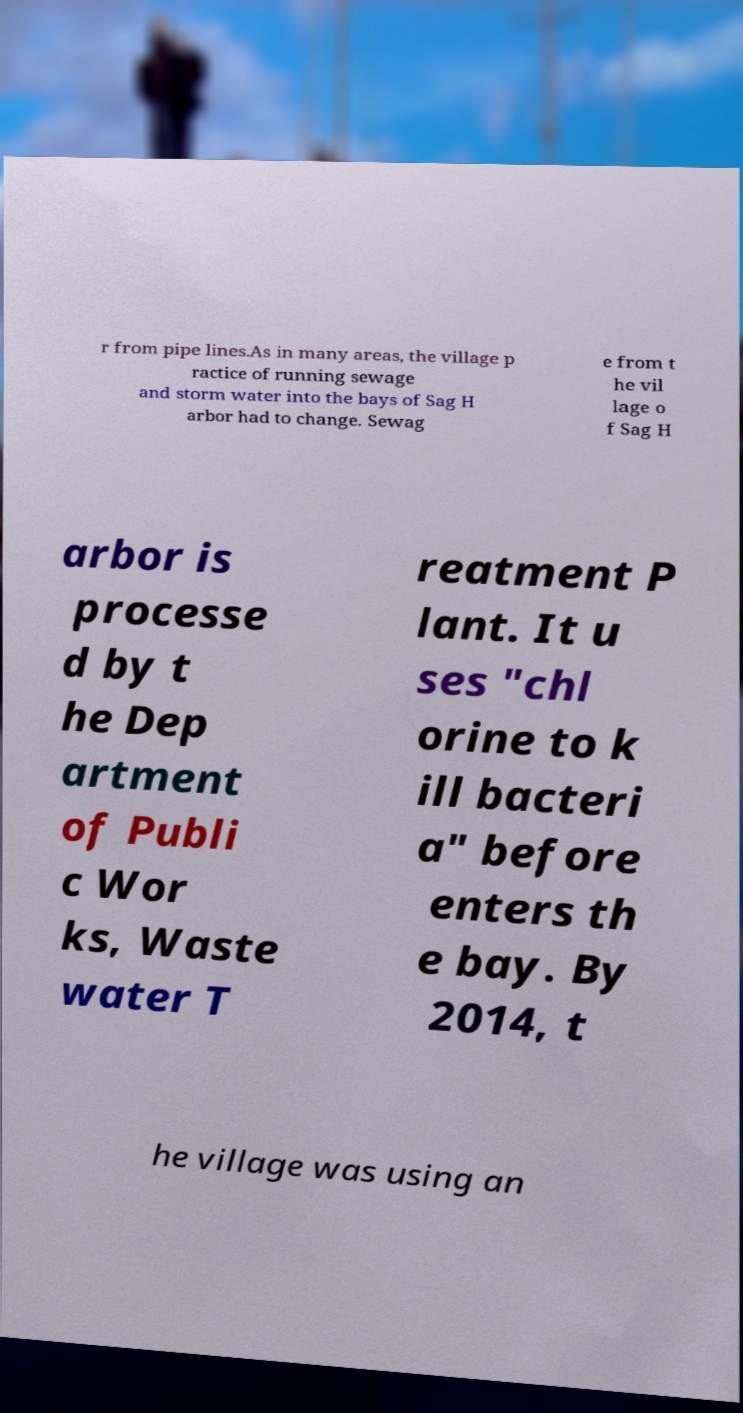Can you accurately transcribe the text from the provided image for me? r from pipe lines.As in many areas, the village p ractice of running sewage and storm water into the bays of Sag H arbor had to change. Sewag e from t he vil lage o f Sag H arbor is processe d by t he Dep artment of Publi c Wor ks, Waste water T reatment P lant. It u ses "chl orine to k ill bacteri a" before enters th e bay. By 2014, t he village was using an 